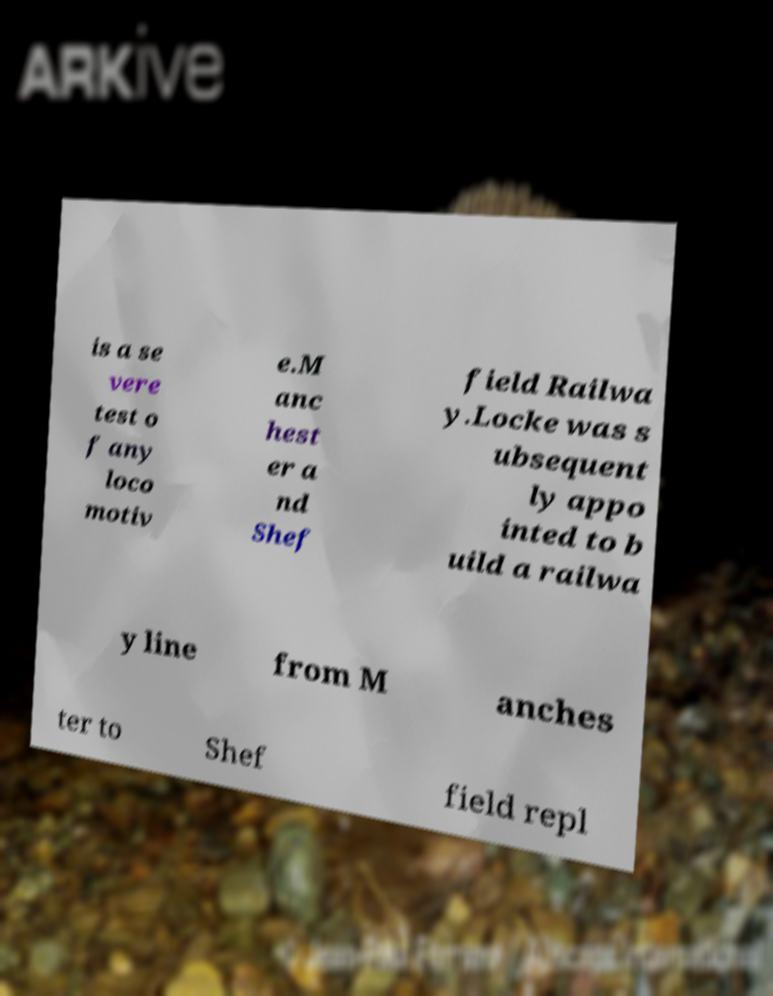Can you read and provide the text displayed in the image?This photo seems to have some interesting text. Can you extract and type it out for me? is a se vere test o f any loco motiv e.M anc hest er a nd Shef field Railwa y.Locke was s ubsequent ly appo inted to b uild a railwa y line from M anches ter to Shef field repl 